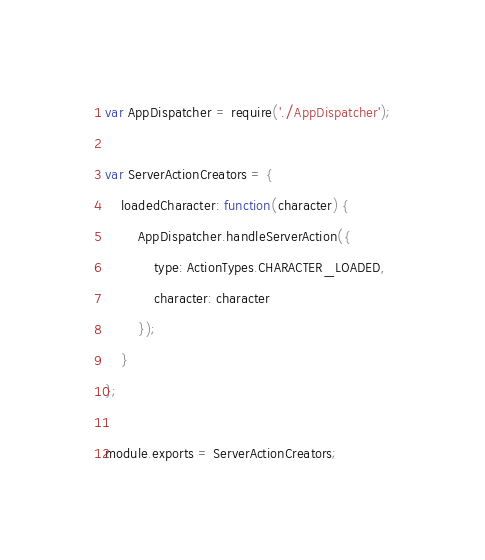Convert code to text. <code><loc_0><loc_0><loc_500><loc_500><_JavaScript_>var AppDispatcher = require('./AppDispatcher');

var ServerActionCreators = {
	loadedCharacter: function(character) {
		AppDispatcher.handleServerAction({
			type: ActionTypes.CHARACTER_LOADED,
			character: character
		});
	}
};

module.exports = ServerActionCreators;
</code> 